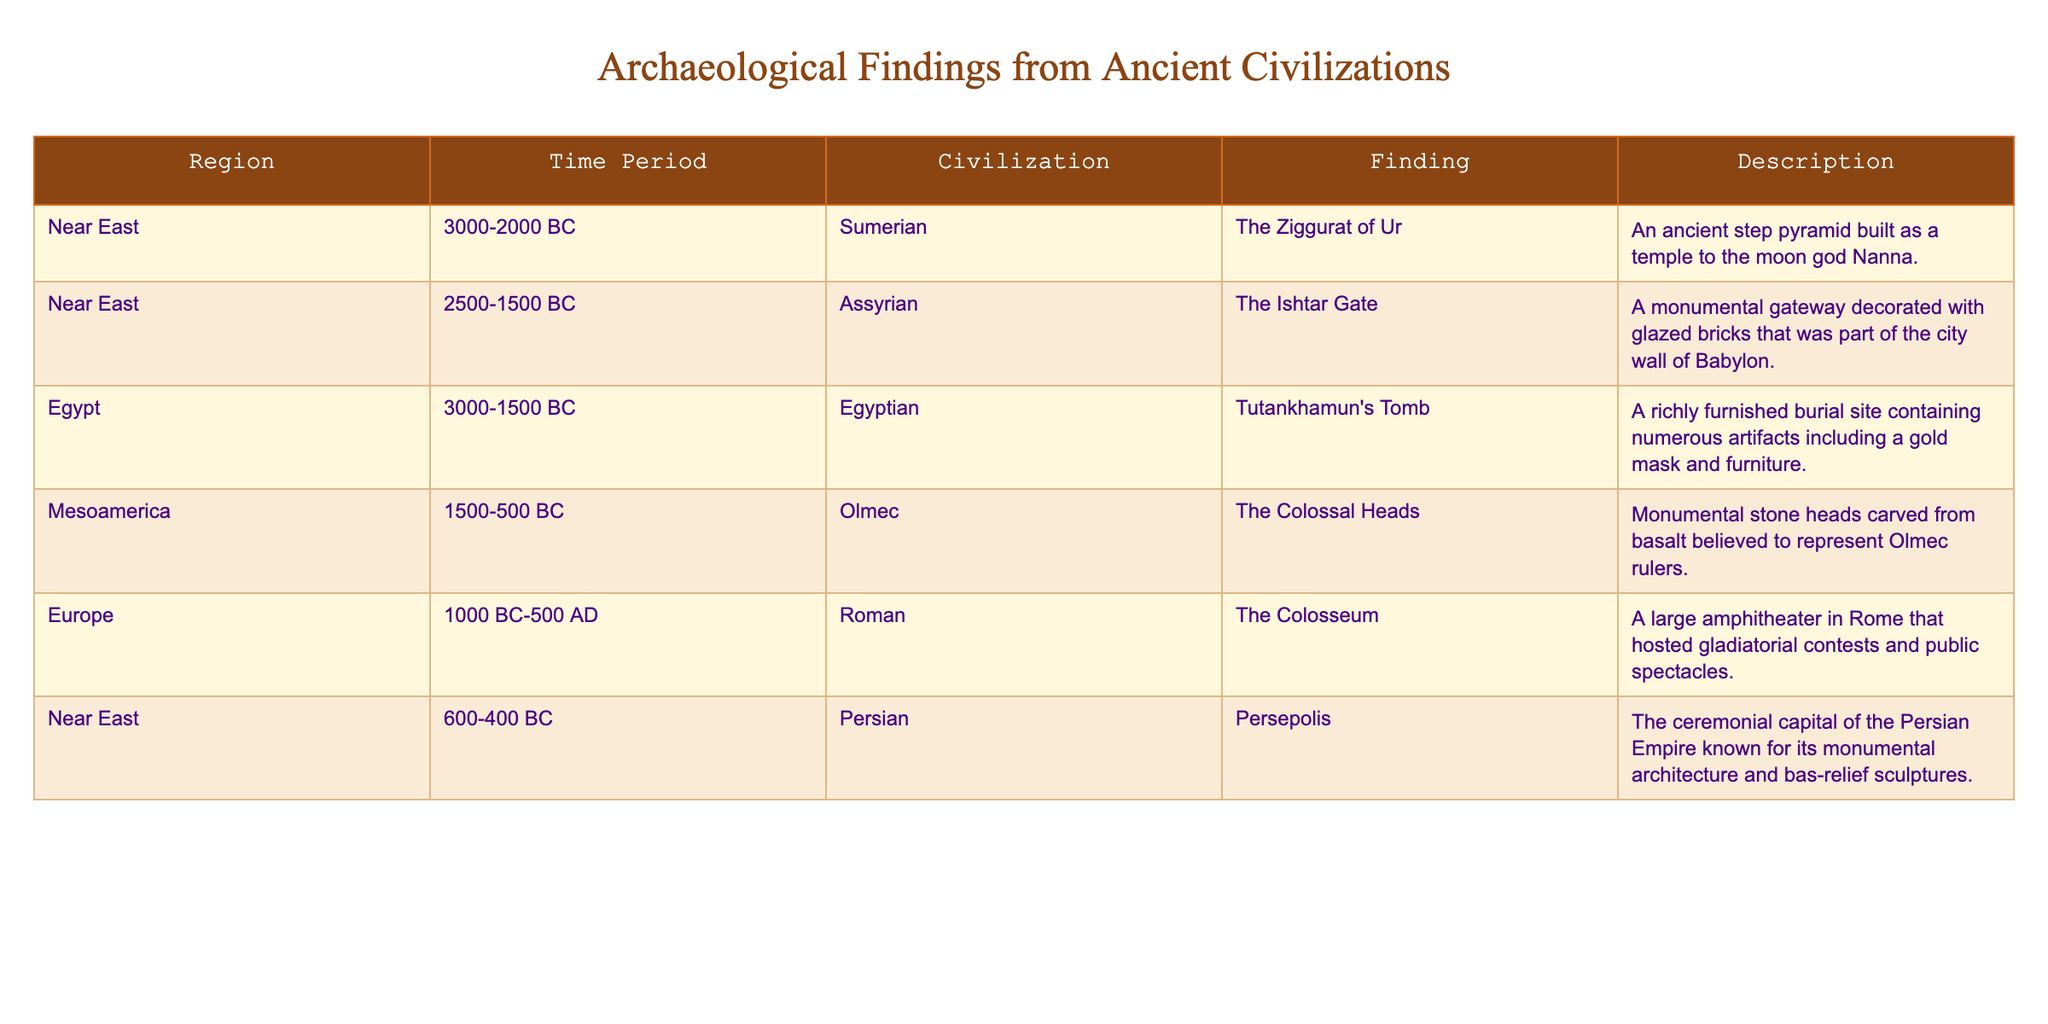What civilization is associated with the finding of the Ziggurat of Ur? The table lists the Ziggurat of Ur under the Sumerian civilization in the Near East region.
Answer: Sumerian What is the time period during which the Colosseum was constructed? The table indicates that the Colosseum falls within the time period of 1000 BC to 500 AD.
Answer: 1000 BC-500 AD How many findings are from the Near East? The table shows three findings from the Near East: The Ziggurat of Ur, The Ishtar Gate, and Persepolis. Counting these gives us three findings.
Answer: 3 Is Tutankhamun's Tomb older than the Ishtar Gate? By comparing the time periods, Tutankhamun's Tomb (3000-1500 BC) is older than the Ishtar Gate (2500-1500 BC), as it starts from an earlier date.
Answer: Yes Which finding is the most recent based on its time period? The findings need to be compared by their ending dates. The Colosseum (500 AD) is the most recent one in the list compared to others.
Answer: The Colosseum Can you list all the civilizations from the table that have findings from the Near East? From the table, the civilizations associated with findings in the Near East are Sumerian, Assyrian, and Persian.
Answer: Sumerian, Assyrian, Persian Which finding was constructed as a temple to the moon god? The Ziggurat of Ur was built as a temple to the moon god Nanna, according to the description in the table.
Answer: The Ziggurat of Ur What is the average time period range (in BC) for the findings from Mesoamerica? The time period of the Olmec finding is 1500-500 BC. There's only one finding in Mesoamerica, so the average is simply its range: 1500-500 BC.
Answer: 1500-500 BC Are there any findings from Europe that date before 1000 BC? The table does not list any findings from Europe dating before 1000 BC, as the only entry is the Colosseum, which is dated starting from 1000 BC.
Answer: No Which region has the earliest finding listed in the table? The earliest finding is Tutankhamun's Tomb from the Egyptian civilization, which dates back to 3000-1500 BC. Checking the time periods reveals it's the earliest.
Answer: Egypt 